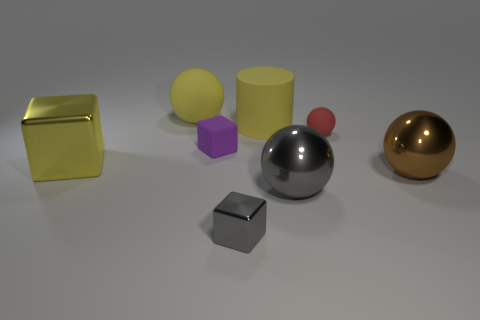Are there fewer large green matte things than small purple matte cubes?
Make the answer very short. Yes. Does the big ball that is in front of the large brown sphere have the same color as the tiny shiny thing?
Provide a short and direct response. Yes. What number of blue matte cylinders are the same size as the yellow matte cylinder?
Keep it short and to the point. 0. Are there any large shiny objects that have the same color as the tiny rubber sphere?
Keep it short and to the point. No. Is the material of the brown object the same as the yellow sphere?
Make the answer very short. No. What number of cyan objects are the same shape as the large brown thing?
Your answer should be compact. 0. The tiny red object that is the same material as the yellow cylinder is what shape?
Ensure brevity in your answer.  Sphere. What color is the small block right of the tiny matte object that is on the left side of the tiny shiny object?
Make the answer very short. Gray. Is the large cylinder the same color as the large rubber sphere?
Offer a very short reply. Yes. What is the material of the block that is behind the yellow object that is in front of the tiny purple object?
Offer a terse response. Rubber. 